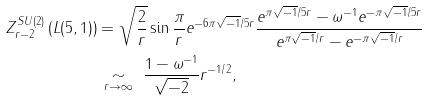<formula> <loc_0><loc_0><loc_500><loc_500>Z _ { r - 2 } ^ { S U ( 2 ) } \left ( L ( 5 , 1 ) \right ) & = \sqrt { \frac { 2 } { r } } \sin \frac { \pi } { r } e ^ { - 6 \pi \sqrt { - 1 } / 5 r } \frac { e ^ { \pi \sqrt { - 1 } / 5 r } - \omega ^ { - 1 } e ^ { - \pi \sqrt { - 1 } / 5 r } } { e ^ { \pi \sqrt { - 1 } / r } - e ^ { - \pi \sqrt { - 1 } / r } } \\ & \, \underset { r \to \infty } { \sim } \ \frac { 1 - \omega ^ { - 1 } } { \sqrt { - 2 } } r ^ { - 1 / 2 } ,</formula> 